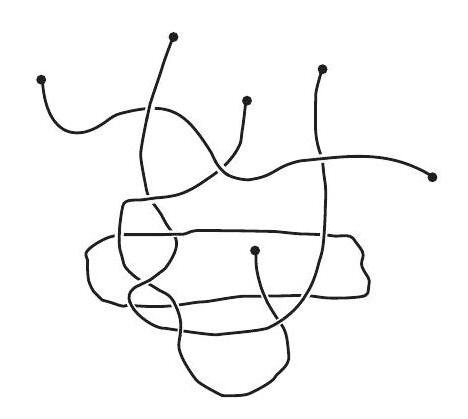Can you describe the pattern formed by the strings? The strings form an intricate pattern with several loops and overlaps, creating a visually engaging abstract design. The lines intersect at various points, adding to its complexity and aesthetic appeal. 